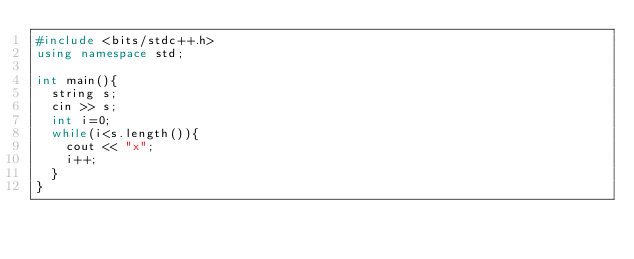Convert code to text. <code><loc_0><loc_0><loc_500><loc_500><_C++_>#include <bits/stdc++.h>
using namespace std;

int main(){
  string s;
  cin >> s;
  int i=0;
  while(i<s.length()){
    cout << "x";
    i++;
  }
}</code> 